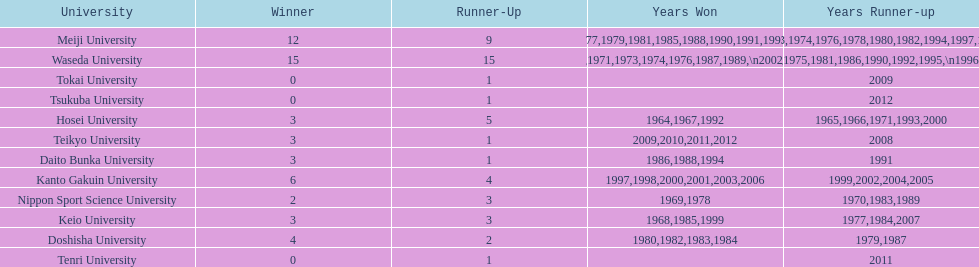Which universities had a number of wins higher than 12? Waseda University. 